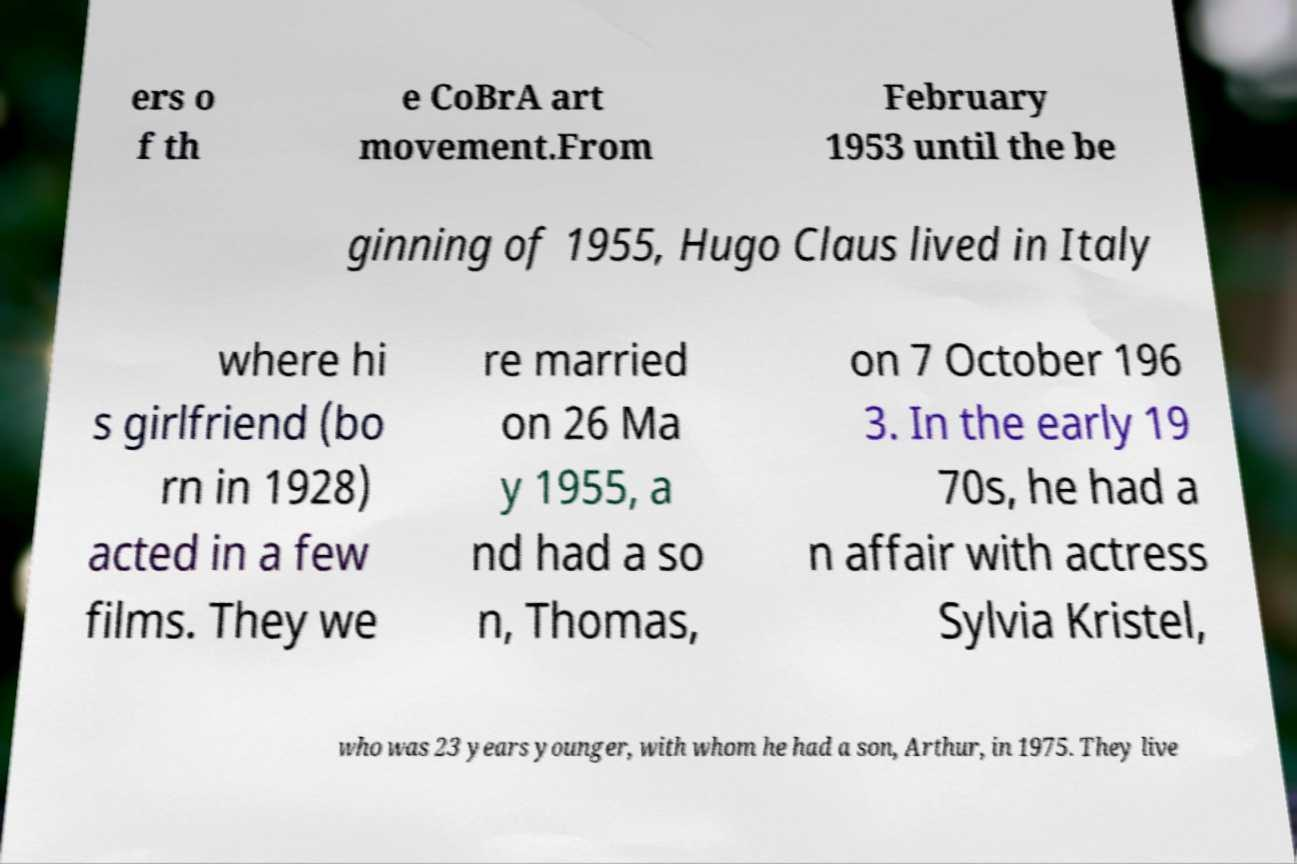There's text embedded in this image that I need extracted. Can you transcribe it verbatim? ers o f th e CoBrA art movement.From February 1953 until the be ginning of 1955, Hugo Claus lived in Italy where hi s girlfriend (bo rn in 1928) acted in a few films. They we re married on 26 Ma y 1955, a nd had a so n, Thomas, on 7 October 196 3. In the early 19 70s, he had a n affair with actress Sylvia Kristel, who was 23 years younger, with whom he had a son, Arthur, in 1975. They live 